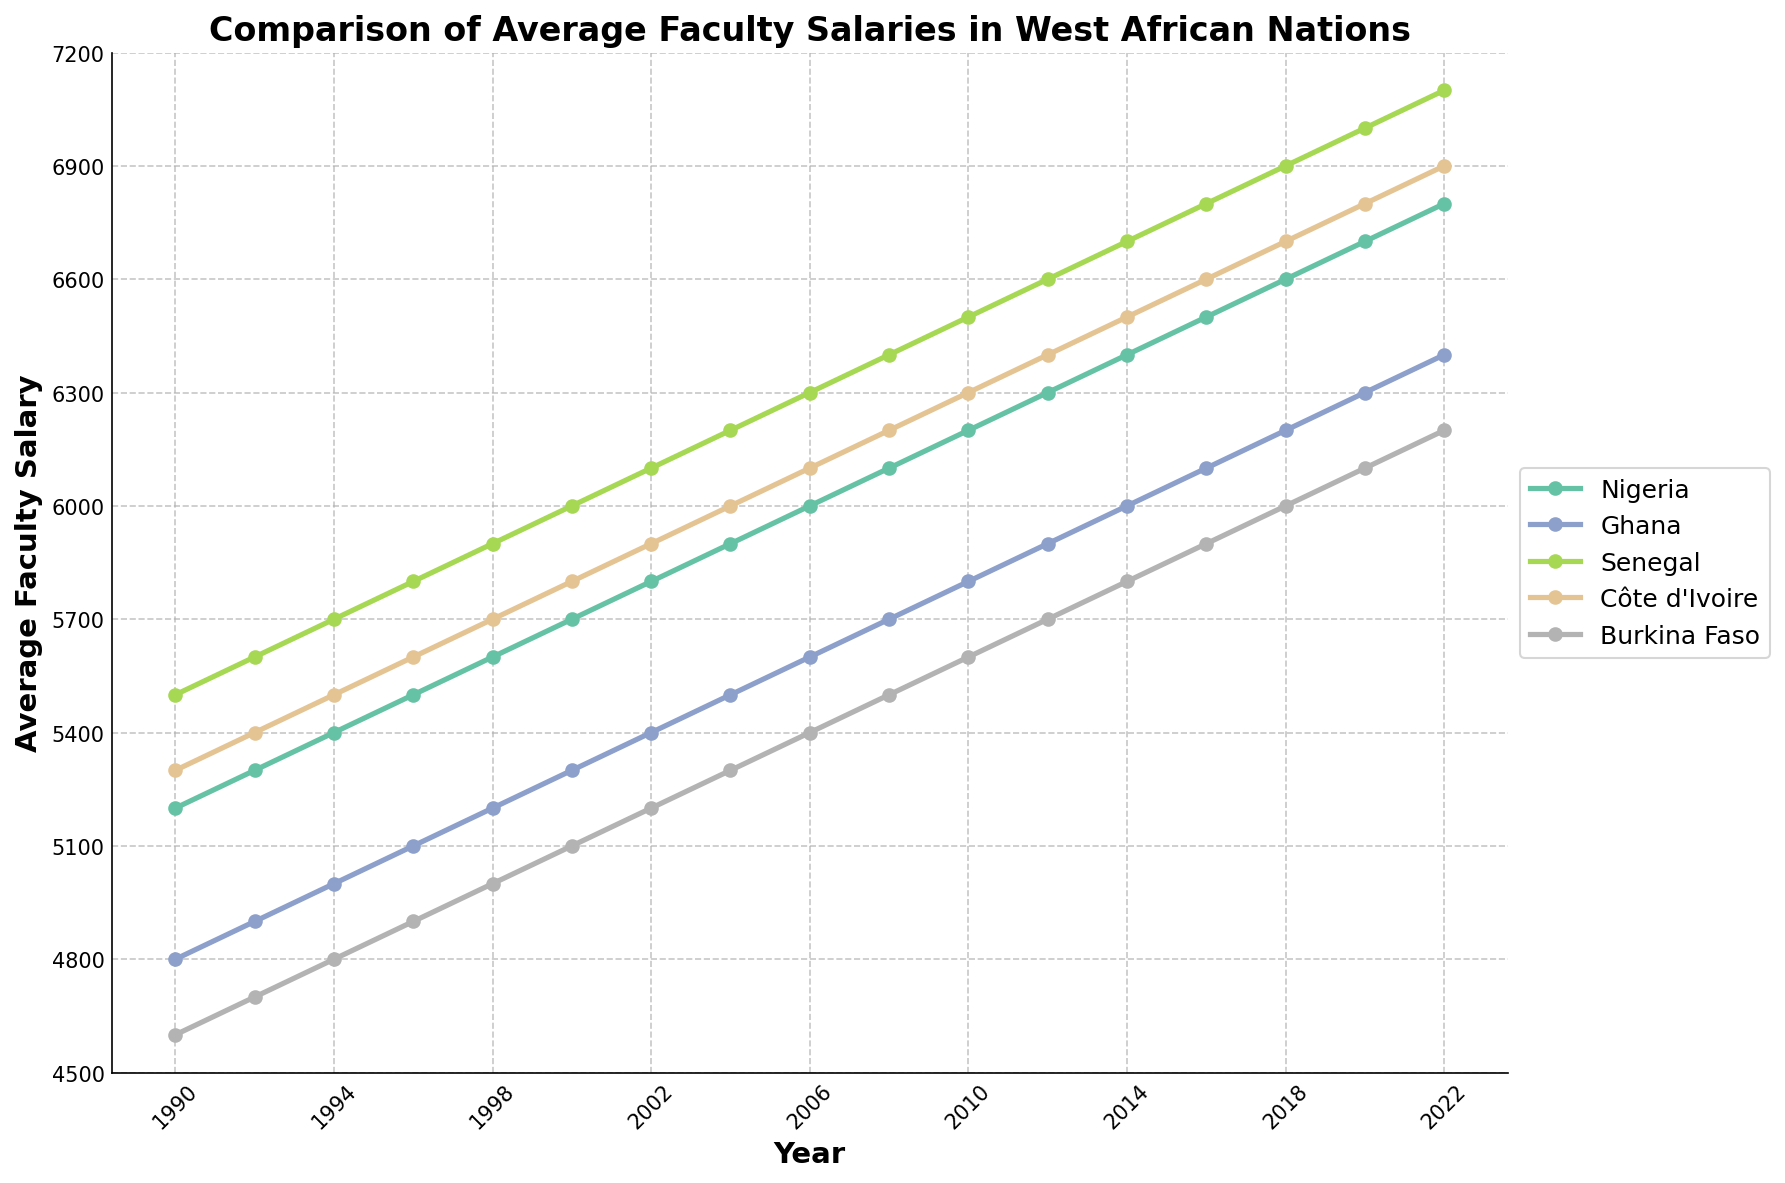What is the trend of average faculty salaries in Nigeria from 1990 to 2022? Observing the line trend for Nigeria, the salary value steadily increases year by year without any decrease, starting from 5200 in 1990 to 6800 in 2022.
Answer: Steadily increasing Which country had the highest faculty salary in 2000? By looking at the figure for the year 2000, it appears that Senegal has the highest value of salaries compared to Nigeria, Ghana, Côte d'Ivoire, and Burkina Faso.
Answer: Senegal How did the average faculty salary in Burkina Faso compare to that in Côte d'Ivoire in 2010? For the year 2010, Burkina Faso's salary is at 5600 while Côte d'Ivoire's is at 6300. Burkina Faso’s salary is lower than Côte d'Ivoire’s.
Answer: Lower Which country experienced the most significant increase in average faculty salary from 1990 to 2022? To determine this, we subtract each country's 1990 salary from their 2022 salary and compare the differences. Nigeria: 6800-5200=1600, Ghana: 6400-4800=1600, Senegal: 7100-5500=1600, Côte d'Ivoire: 6900-5300=1600, Burkina Faso: 6200-4600=1600. Thus, all of these countries experienced the same increase.
Answer: Equal increase for all What is the difference between Ghana's and Senegal's salaries in 2008? Ghana's salary in 2008 is 5700, and Senegal's salary in 2008 is 6400. The difference is 6400 - 5700 = 700.
Answer: 700 In what year did Côte d'Ivoire’s faculty salaries surpass 6000? Checking the trends for Côte d'Ivoire, the value crosses 6000 between 2004 and 2008, so it first surpasses 6000 in 2006.
Answer: 2006 Which country's faculty salaries remained consistently lower than 6000 till 2020? From the plot, Burkina Faso's salary remained below 6000 until 2020.
Answer: Burkina Faso What was the average salary of faculty members in Ghana during the first decade (1990-2000)? Adding the salary values for Ghana from 1990 to 2000 and dividing by the number of years: (4800+4900+5000+5100+5200+5300)/6 = 5050.
Answer: 5050 Which country had the smallest increase in faculty salaries from 2016 to 2022? Calculating the increase from 2016 to 2022: Nigeria: 6800-6500=300, Ghana: 6400-6100=300, Senegal: 7100-6800=300, Côte d'Ivoire: 6900-6600=300, Burkina Faso: 6200-5900=300. All countries had the same increase.
Answer: Equal increase for all Is there a year where all countries saw an increase in faculty salaries compared to the previous year? Inspecting each consecutive year, it appears that there are consistent annual increases for all countries in each period shown in the graph.
Answer: Yes, in all years 